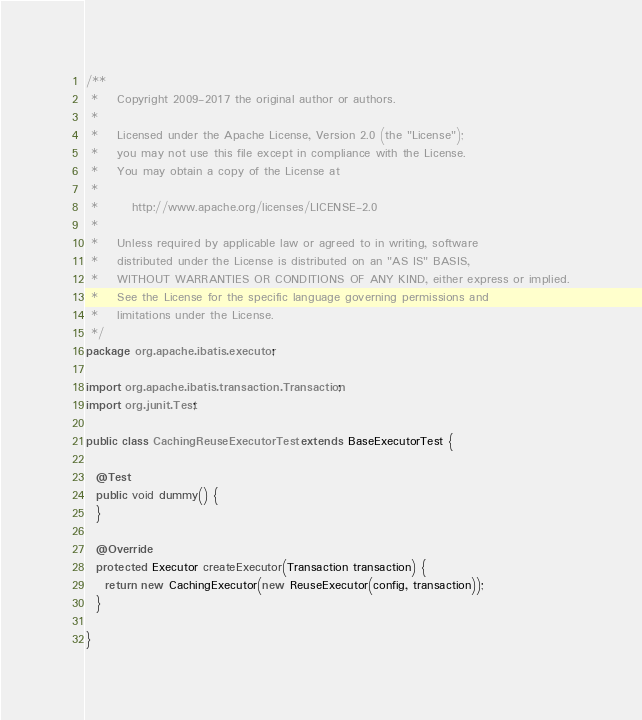Convert code to text. <code><loc_0><loc_0><loc_500><loc_500><_Java_>/**
 *    Copyright 2009-2017 the original author or authors.
 *
 *    Licensed under the Apache License, Version 2.0 (the "License");
 *    you may not use this file except in compliance with the License.
 *    You may obtain a copy of the License at
 *
 *       http://www.apache.org/licenses/LICENSE-2.0
 *
 *    Unless required by applicable law or agreed to in writing, software
 *    distributed under the License is distributed on an "AS IS" BASIS,
 *    WITHOUT WARRANTIES OR CONDITIONS OF ANY KIND, either express or implied.
 *    See the License for the specific language governing permissions and
 *    limitations under the License.
 */
package org.apache.ibatis.executor;

import org.apache.ibatis.transaction.Transaction;
import org.junit.Test;

public class CachingReuseExecutorTest extends BaseExecutorTest {

  @Test
  public void dummy() {
  }

  @Override
  protected Executor createExecutor(Transaction transaction) {
    return new CachingExecutor(new ReuseExecutor(config, transaction));
  }

}</code> 